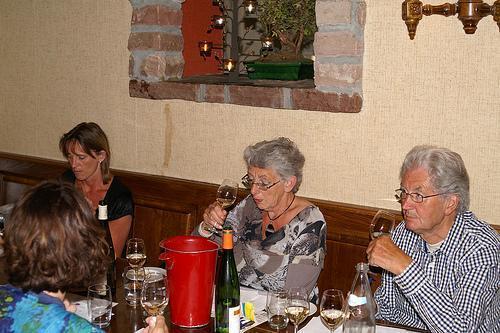How many people at the table?
Give a very brief answer. 4. How many wine bottles on the table?
Give a very brief answer. 2. How many wine glasses can be seen?
Give a very brief answer. 6. How many people holding wine glasses?
Give a very brief answer. 3. 